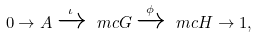<formula> <loc_0><loc_0><loc_500><loc_500>0 \to A \xrightarrow { \iota } \ m c { G } \xrightarrow { \phi } \ m c { H } \to 1 ,</formula> 